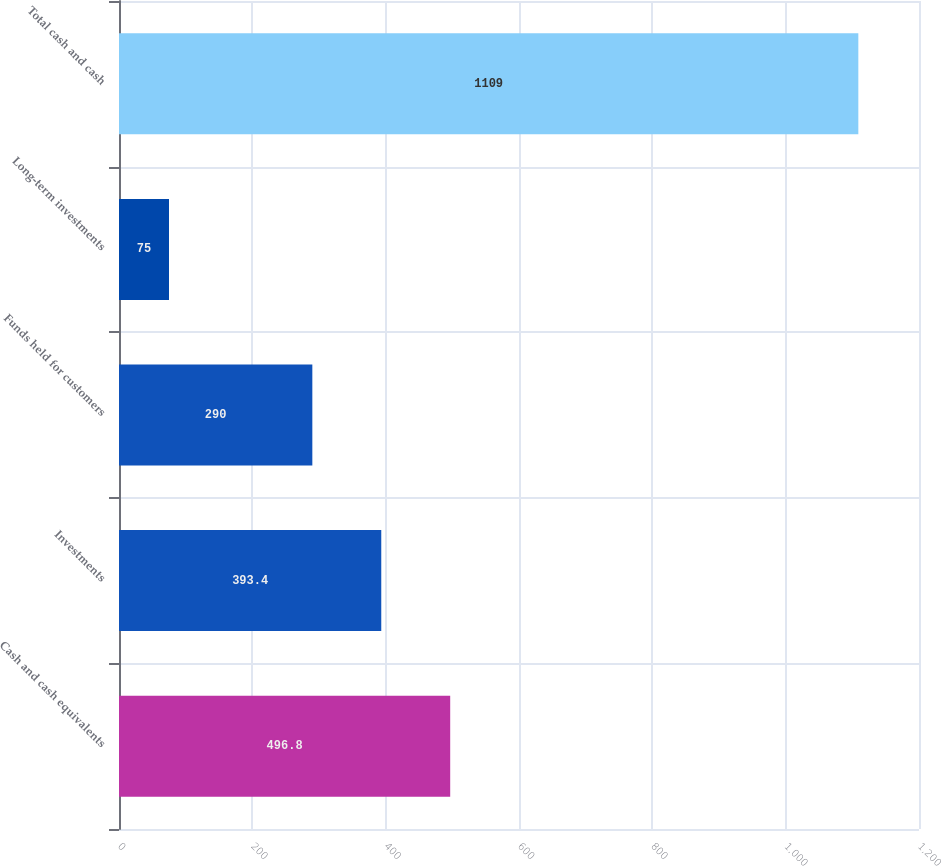Convert chart to OTSL. <chart><loc_0><loc_0><loc_500><loc_500><bar_chart><fcel>Cash and cash equivalents<fcel>Investments<fcel>Funds held for customers<fcel>Long-term investments<fcel>Total cash and cash<nl><fcel>496.8<fcel>393.4<fcel>290<fcel>75<fcel>1109<nl></chart> 